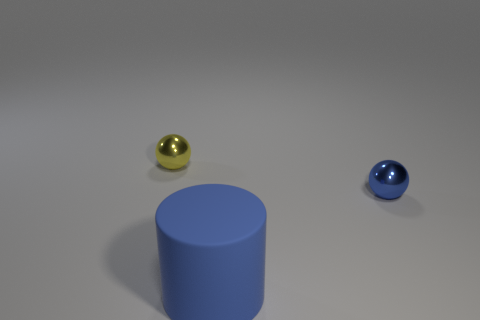Is there any other thing that is the same size as the cylinder?
Offer a terse response. No. What color is the thing that is both in front of the yellow metallic sphere and behind the big rubber cylinder?
Offer a very short reply. Blue. Are there any other things that are the same material as the large blue cylinder?
Your answer should be compact. No. Do the yellow ball and the blue object that is right of the big blue cylinder have the same material?
Your answer should be compact. Yes. There is a shiny object that is behind the metallic thing in front of the yellow sphere; what size is it?
Offer a terse response. Small. Are there any other things that have the same color as the big cylinder?
Make the answer very short. Yes. Are the sphere that is in front of the yellow ball and the small ball that is left of the big blue cylinder made of the same material?
Offer a very short reply. Yes. What is the thing that is behind the large blue thing and to the left of the blue metal ball made of?
Provide a short and direct response. Metal. Is the shape of the yellow shiny object the same as the small metal object that is right of the matte cylinder?
Your answer should be very brief. Yes. There is a blue thing that is behind the rubber cylinder that is right of the small sphere on the left side of the large cylinder; what is it made of?
Offer a very short reply. Metal. 